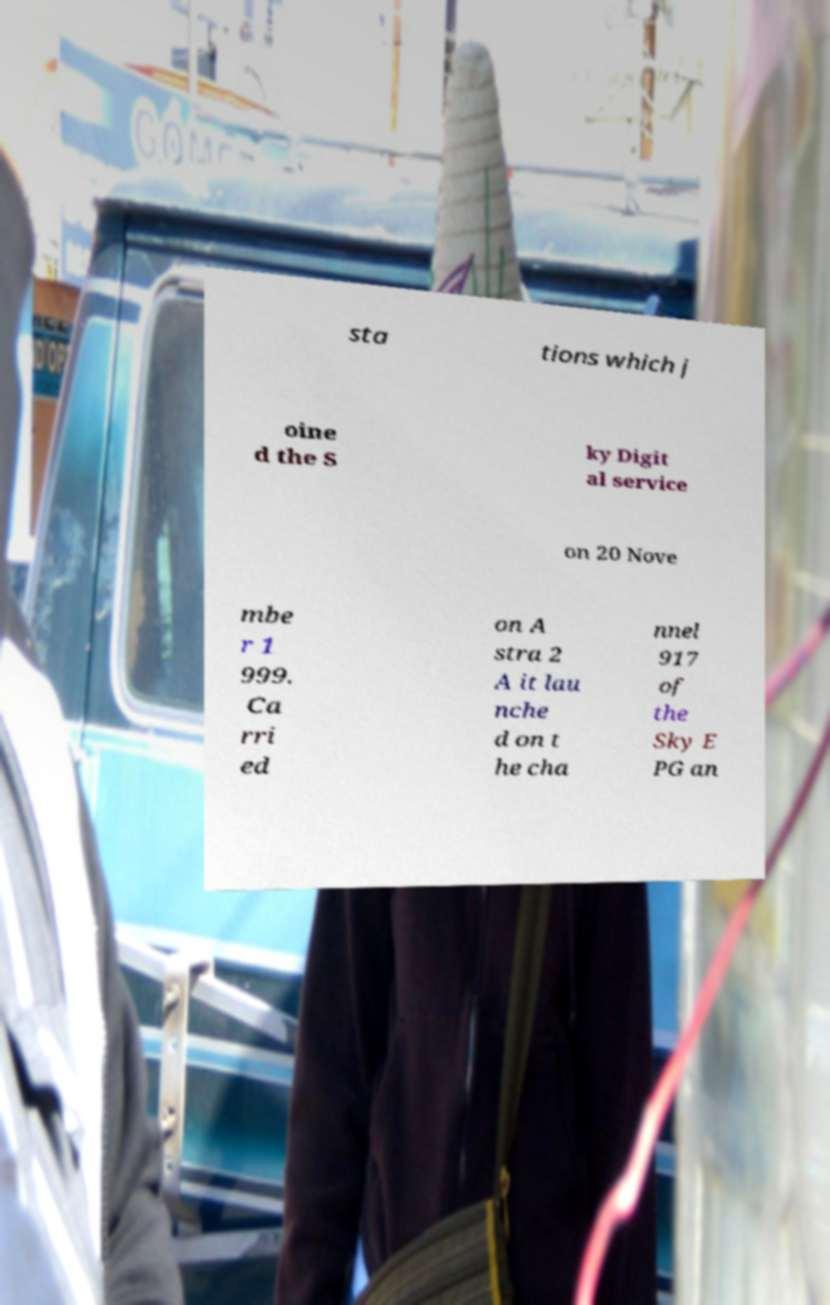What messages or text are displayed in this image? I need them in a readable, typed format. sta tions which j oine d the S ky Digit al service on 20 Nove mbe r 1 999. Ca rri ed on A stra 2 A it lau nche d on t he cha nnel 917 of the Sky E PG an 